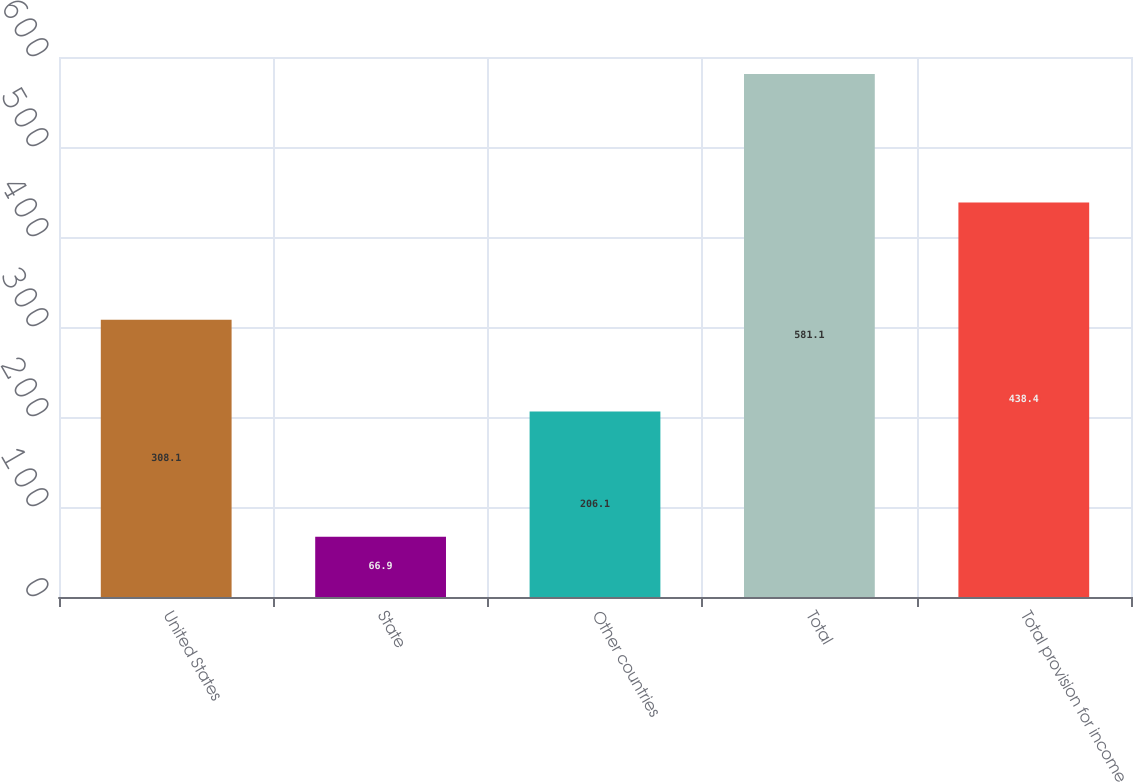Convert chart. <chart><loc_0><loc_0><loc_500><loc_500><bar_chart><fcel>United States<fcel>State<fcel>Other countries<fcel>Total<fcel>Total provision for income<nl><fcel>308.1<fcel>66.9<fcel>206.1<fcel>581.1<fcel>438.4<nl></chart> 